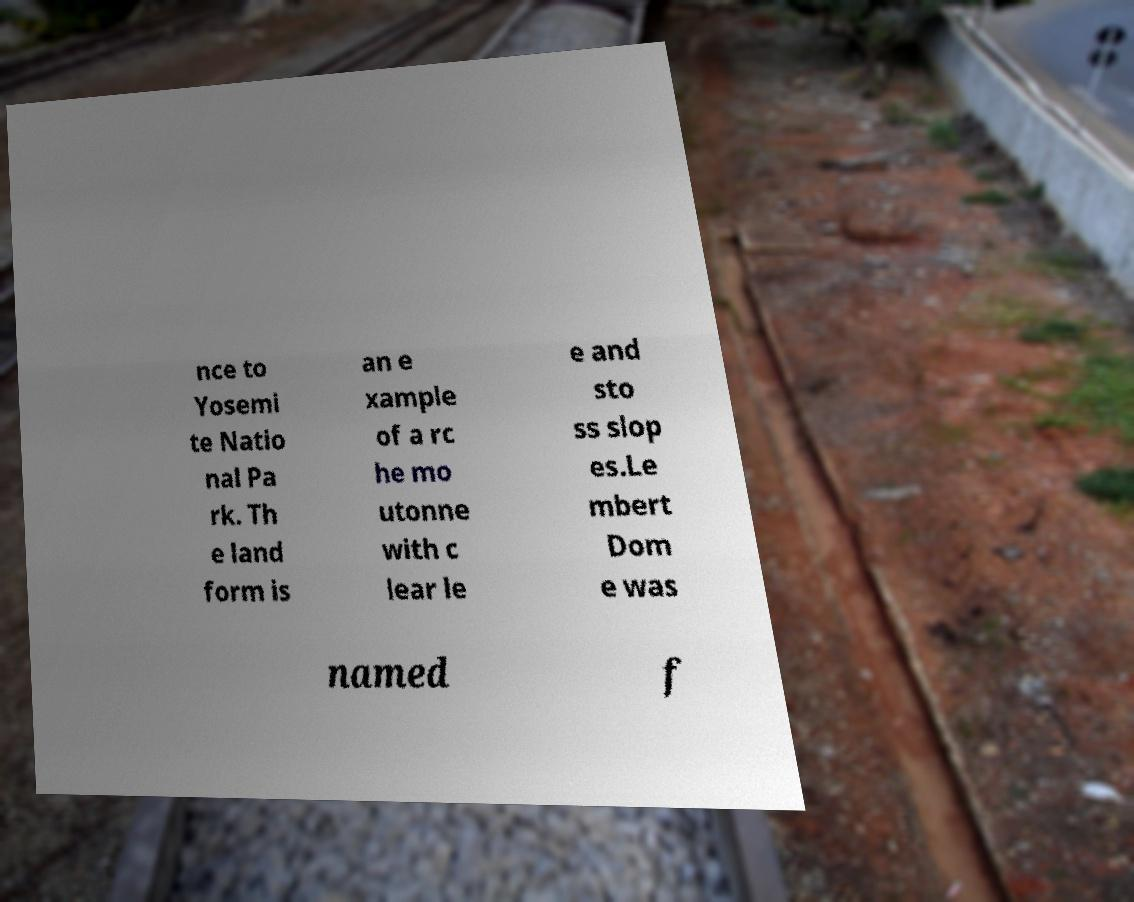Can you accurately transcribe the text from the provided image for me? nce to Yosemi te Natio nal Pa rk. Th e land form is an e xample of a rc he mo utonne with c lear le e and sto ss slop es.Le mbert Dom e was named f 